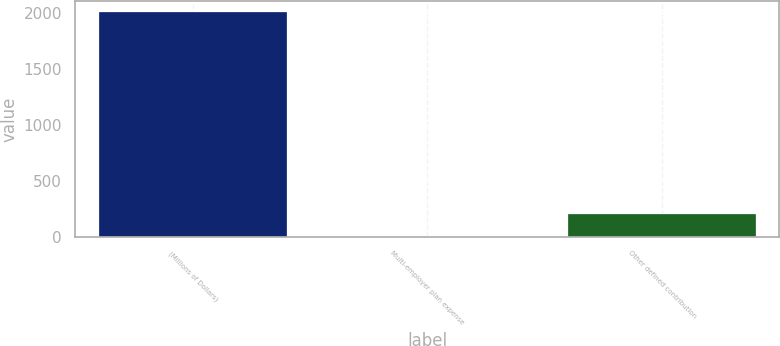<chart> <loc_0><loc_0><loc_500><loc_500><bar_chart><fcel>(Millions of Dollars)<fcel>Multi-employer plan expense<fcel>Other defined contribution<nl><fcel>2003<fcel>0.5<fcel>200.75<nl></chart> 